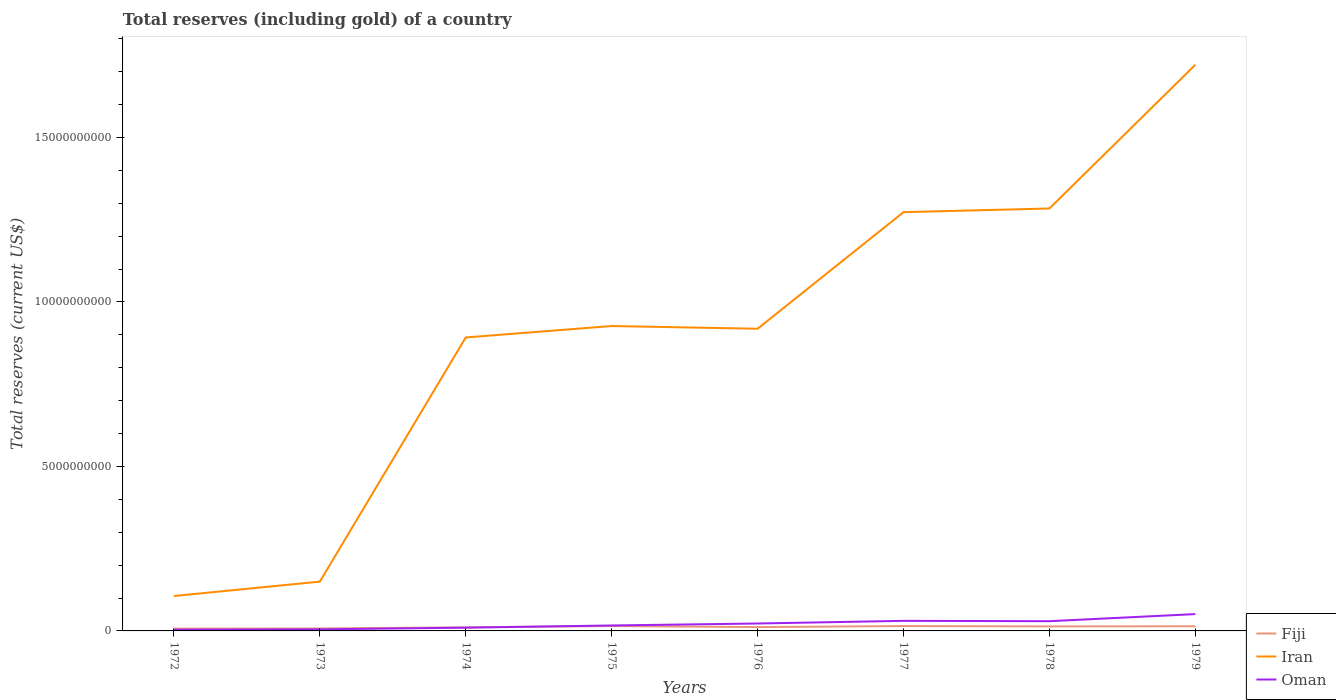How many different coloured lines are there?
Ensure brevity in your answer.  3. Is the number of lines equal to the number of legend labels?
Provide a short and direct response. Yes. Across all years, what is the maximum total reserves (including gold) in Oman?
Provide a succinct answer. 3.73e+07. What is the total total reserves (including gold) in Iran in the graph?
Offer a very short reply. -1.61e+1. What is the difference between the highest and the second highest total reserves (including gold) in Fiji?
Provide a short and direct response. 7.92e+07. Is the total reserves (including gold) in Fiji strictly greater than the total reserves (including gold) in Oman over the years?
Your response must be concise. No. What is the difference between two consecutive major ticks on the Y-axis?
Ensure brevity in your answer.  5.00e+09. Are the values on the major ticks of Y-axis written in scientific E-notation?
Offer a terse response. No. Does the graph contain grids?
Provide a short and direct response. No. How many legend labels are there?
Provide a succinct answer. 3. What is the title of the graph?
Provide a short and direct response. Total reserves (including gold) of a country. What is the label or title of the Y-axis?
Provide a succinct answer. Total reserves (current US$). What is the Total reserves (current US$) of Fiji in 1972?
Make the answer very short. 6.94e+07. What is the Total reserves (current US$) of Iran in 1972?
Give a very brief answer. 1.06e+09. What is the Total reserves (current US$) of Oman in 1972?
Give a very brief answer. 3.73e+07. What is the Total reserves (current US$) of Fiji in 1973?
Your response must be concise. 7.39e+07. What is the Total reserves (current US$) of Iran in 1973?
Ensure brevity in your answer.  1.50e+09. What is the Total reserves (current US$) in Oman in 1973?
Offer a very short reply. 4.86e+07. What is the Total reserves (current US$) in Fiji in 1974?
Keep it short and to the point. 1.09e+08. What is the Total reserves (current US$) in Iran in 1974?
Keep it short and to the point. 8.92e+09. What is the Total reserves (current US$) of Oman in 1974?
Provide a short and direct response. 9.85e+07. What is the Total reserves (current US$) of Fiji in 1975?
Make the answer very short. 1.49e+08. What is the Total reserves (current US$) of Iran in 1975?
Give a very brief answer. 9.27e+09. What is the Total reserves (current US$) in Oman in 1975?
Give a very brief answer. 1.66e+08. What is the Total reserves (current US$) of Fiji in 1976?
Provide a succinct answer. 1.16e+08. What is the Total reserves (current US$) in Iran in 1976?
Keep it short and to the point. 9.18e+09. What is the Total reserves (current US$) of Oman in 1976?
Provide a short and direct response. 2.26e+08. What is the Total reserves (current US$) of Fiji in 1977?
Your answer should be compact. 1.48e+08. What is the Total reserves (current US$) of Iran in 1977?
Ensure brevity in your answer.  1.27e+1. What is the Total reserves (current US$) in Oman in 1977?
Ensure brevity in your answer.  3.06e+08. What is the Total reserves (current US$) of Fiji in 1978?
Give a very brief answer. 1.37e+08. What is the Total reserves (current US$) in Iran in 1978?
Provide a short and direct response. 1.28e+1. What is the Total reserves (current US$) of Oman in 1978?
Give a very brief answer. 2.96e+08. What is the Total reserves (current US$) of Fiji in 1979?
Your response must be concise. 1.42e+08. What is the Total reserves (current US$) of Iran in 1979?
Your answer should be very brief. 1.72e+1. What is the Total reserves (current US$) in Oman in 1979?
Keep it short and to the point. 5.11e+08. Across all years, what is the maximum Total reserves (current US$) of Fiji?
Provide a short and direct response. 1.49e+08. Across all years, what is the maximum Total reserves (current US$) of Iran?
Make the answer very short. 1.72e+1. Across all years, what is the maximum Total reserves (current US$) of Oman?
Ensure brevity in your answer.  5.11e+08. Across all years, what is the minimum Total reserves (current US$) in Fiji?
Keep it short and to the point. 6.94e+07. Across all years, what is the minimum Total reserves (current US$) of Iran?
Provide a short and direct response. 1.06e+09. Across all years, what is the minimum Total reserves (current US$) in Oman?
Provide a short and direct response. 3.73e+07. What is the total Total reserves (current US$) of Fiji in the graph?
Your answer should be compact. 9.44e+08. What is the total Total reserves (current US$) of Iran in the graph?
Offer a very short reply. 7.27e+1. What is the total Total reserves (current US$) in Oman in the graph?
Offer a very short reply. 1.69e+09. What is the difference between the Total reserves (current US$) of Fiji in 1972 and that in 1973?
Give a very brief answer. -4.53e+06. What is the difference between the Total reserves (current US$) in Iran in 1972 and that in 1973?
Provide a succinct answer. -4.37e+08. What is the difference between the Total reserves (current US$) in Oman in 1972 and that in 1973?
Provide a succinct answer. -1.13e+07. What is the difference between the Total reserves (current US$) in Fiji in 1972 and that in 1974?
Offer a very short reply. -3.97e+07. What is the difference between the Total reserves (current US$) in Iran in 1972 and that in 1974?
Provide a short and direct response. -7.86e+09. What is the difference between the Total reserves (current US$) of Oman in 1972 and that in 1974?
Keep it short and to the point. -6.12e+07. What is the difference between the Total reserves (current US$) of Fiji in 1972 and that in 1975?
Your response must be concise. -7.92e+07. What is the difference between the Total reserves (current US$) in Iran in 1972 and that in 1975?
Provide a short and direct response. -8.21e+09. What is the difference between the Total reserves (current US$) of Oman in 1972 and that in 1975?
Your answer should be very brief. -1.28e+08. What is the difference between the Total reserves (current US$) in Fiji in 1972 and that in 1976?
Make the answer very short. -4.69e+07. What is the difference between the Total reserves (current US$) of Iran in 1972 and that in 1976?
Provide a short and direct response. -8.12e+09. What is the difference between the Total reserves (current US$) of Oman in 1972 and that in 1976?
Provide a succinct answer. -1.88e+08. What is the difference between the Total reserves (current US$) in Fiji in 1972 and that in 1977?
Your response must be concise. -7.86e+07. What is the difference between the Total reserves (current US$) in Iran in 1972 and that in 1977?
Your response must be concise. -1.17e+1. What is the difference between the Total reserves (current US$) in Oman in 1972 and that in 1977?
Your response must be concise. -2.69e+08. What is the difference between the Total reserves (current US$) of Fiji in 1972 and that in 1978?
Provide a short and direct response. -6.72e+07. What is the difference between the Total reserves (current US$) in Iran in 1972 and that in 1978?
Offer a terse response. -1.18e+1. What is the difference between the Total reserves (current US$) of Oman in 1972 and that in 1978?
Provide a short and direct response. -2.59e+08. What is the difference between the Total reserves (current US$) in Fiji in 1972 and that in 1979?
Your response must be concise. -7.28e+07. What is the difference between the Total reserves (current US$) of Iran in 1972 and that in 1979?
Give a very brief answer. -1.61e+1. What is the difference between the Total reserves (current US$) in Oman in 1972 and that in 1979?
Offer a terse response. -4.74e+08. What is the difference between the Total reserves (current US$) in Fiji in 1973 and that in 1974?
Offer a terse response. -3.52e+07. What is the difference between the Total reserves (current US$) in Iran in 1973 and that in 1974?
Offer a very short reply. -7.42e+09. What is the difference between the Total reserves (current US$) in Oman in 1973 and that in 1974?
Offer a terse response. -4.99e+07. What is the difference between the Total reserves (current US$) in Fiji in 1973 and that in 1975?
Offer a very short reply. -7.46e+07. What is the difference between the Total reserves (current US$) in Iran in 1973 and that in 1975?
Offer a terse response. -7.77e+09. What is the difference between the Total reserves (current US$) in Oman in 1973 and that in 1975?
Make the answer very short. -1.17e+08. What is the difference between the Total reserves (current US$) in Fiji in 1973 and that in 1976?
Ensure brevity in your answer.  -4.24e+07. What is the difference between the Total reserves (current US$) in Iran in 1973 and that in 1976?
Provide a succinct answer. -7.69e+09. What is the difference between the Total reserves (current US$) in Oman in 1973 and that in 1976?
Offer a very short reply. -1.77e+08. What is the difference between the Total reserves (current US$) of Fiji in 1973 and that in 1977?
Give a very brief answer. -7.41e+07. What is the difference between the Total reserves (current US$) in Iran in 1973 and that in 1977?
Your answer should be compact. -1.12e+1. What is the difference between the Total reserves (current US$) in Oman in 1973 and that in 1977?
Offer a very short reply. -2.58e+08. What is the difference between the Total reserves (current US$) in Fiji in 1973 and that in 1978?
Your response must be concise. -6.26e+07. What is the difference between the Total reserves (current US$) in Iran in 1973 and that in 1978?
Offer a terse response. -1.13e+1. What is the difference between the Total reserves (current US$) in Oman in 1973 and that in 1978?
Your response must be concise. -2.47e+08. What is the difference between the Total reserves (current US$) in Fiji in 1973 and that in 1979?
Your answer should be very brief. -6.82e+07. What is the difference between the Total reserves (current US$) in Iran in 1973 and that in 1979?
Your answer should be very brief. -1.57e+1. What is the difference between the Total reserves (current US$) of Oman in 1973 and that in 1979?
Your answer should be very brief. -4.63e+08. What is the difference between the Total reserves (current US$) of Fiji in 1974 and that in 1975?
Give a very brief answer. -3.94e+07. What is the difference between the Total reserves (current US$) of Iran in 1974 and that in 1975?
Your answer should be very brief. -3.48e+08. What is the difference between the Total reserves (current US$) in Oman in 1974 and that in 1975?
Make the answer very short. -6.70e+07. What is the difference between the Total reserves (current US$) of Fiji in 1974 and that in 1976?
Your answer should be very brief. -7.17e+06. What is the difference between the Total reserves (current US$) in Iran in 1974 and that in 1976?
Your answer should be very brief. -2.65e+08. What is the difference between the Total reserves (current US$) of Oman in 1974 and that in 1976?
Your response must be concise. -1.27e+08. What is the difference between the Total reserves (current US$) in Fiji in 1974 and that in 1977?
Keep it short and to the point. -3.89e+07. What is the difference between the Total reserves (current US$) in Iran in 1974 and that in 1977?
Give a very brief answer. -3.81e+09. What is the difference between the Total reserves (current US$) of Oman in 1974 and that in 1977?
Give a very brief answer. -2.08e+08. What is the difference between the Total reserves (current US$) in Fiji in 1974 and that in 1978?
Your response must be concise. -2.74e+07. What is the difference between the Total reserves (current US$) of Iran in 1974 and that in 1978?
Your answer should be compact. -3.92e+09. What is the difference between the Total reserves (current US$) of Oman in 1974 and that in 1978?
Your answer should be very brief. -1.97e+08. What is the difference between the Total reserves (current US$) in Fiji in 1974 and that in 1979?
Provide a short and direct response. -3.30e+07. What is the difference between the Total reserves (current US$) of Iran in 1974 and that in 1979?
Offer a very short reply. -8.29e+09. What is the difference between the Total reserves (current US$) in Oman in 1974 and that in 1979?
Provide a succinct answer. -4.13e+08. What is the difference between the Total reserves (current US$) in Fiji in 1975 and that in 1976?
Offer a very short reply. 3.23e+07. What is the difference between the Total reserves (current US$) in Iran in 1975 and that in 1976?
Make the answer very short. 8.29e+07. What is the difference between the Total reserves (current US$) in Oman in 1975 and that in 1976?
Provide a short and direct response. -6.03e+07. What is the difference between the Total reserves (current US$) in Fiji in 1975 and that in 1977?
Your answer should be very brief. 5.37e+05. What is the difference between the Total reserves (current US$) in Iran in 1975 and that in 1977?
Ensure brevity in your answer.  -3.46e+09. What is the difference between the Total reserves (current US$) of Oman in 1975 and that in 1977?
Give a very brief answer. -1.41e+08. What is the difference between the Total reserves (current US$) in Fiji in 1975 and that in 1978?
Provide a succinct answer. 1.20e+07. What is the difference between the Total reserves (current US$) of Iran in 1975 and that in 1978?
Offer a terse response. -3.57e+09. What is the difference between the Total reserves (current US$) in Oman in 1975 and that in 1978?
Keep it short and to the point. -1.30e+08. What is the difference between the Total reserves (current US$) in Fiji in 1975 and that in 1979?
Make the answer very short. 6.42e+06. What is the difference between the Total reserves (current US$) in Iran in 1975 and that in 1979?
Keep it short and to the point. -7.94e+09. What is the difference between the Total reserves (current US$) in Oman in 1975 and that in 1979?
Offer a terse response. -3.46e+08. What is the difference between the Total reserves (current US$) of Fiji in 1976 and that in 1977?
Ensure brevity in your answer.  -3.17e+07. What is the difference between the Total reserves (current US$) of Iran in 1976 and that in 1977?
Your response must be concise. -3.54e+09. What is the difference between the Total reserves (current US$) in Oman in 1976 and that in 1977?
Ensure brevity in your answer.  -8.05e+07. What is the difference between the Total reserves (current US$) of Fiji in 1976 and that in 1978?
Give a very brief answer. -2.03e+07. What is the difference between the Total reserves (current US$) of Iran in 1976 and that in 1978?
Make the answer very short. -3.66e+09. What is the difference between the Total reserves (current US$) in Oman in 1976 and that in 1978?
Give a very brief answer. -7.02e+07. What is the difference between the Total reserves (current US$) in Fiji in 1976 and that in 1979?
Make the answer very short. -2.58e+07. What is the difference between the Total reserves (current US$) in Iran in 1976 and that in 1979?
Ensure brevity in your answer.  -8.02e+09. What is the difference between the Total reserves (current US$) of Oman in 1976 and that in 1979?
Your answer should be very brief. -2.86e+08. What is the difference between the Total reserves (current US$) of Fiji in 1977 and that in 1978?
Provide a succinct answer. 1.15e+07. What is the difference between the Total reserves (current US$) of Iran in 1977 and that in 1978?
Your response must be concise. -1.11e+08. What is the difference between the Total reserves (current US$) of Oman in 1977 and that in 1978?
Your answer should be compact. 1.03e+07. What is the difference between the Total reserves (current US$) of Fiji in 1977 and that in 1979?
Provide a short and direct response. 5.89e+06. What is the difference between the Total reserves (current US$) of Iran in 1977 and that in 1979?
Your answer should be very brief. -4.48e+09. What is the difference between the Total reserves (current US$) of Oman in 1977 and that in 1979?
Offer a very short reply. -2.05e+08. What is the difference between the Total reserves (current US$) in Fiji in 1978 and that in 1979?
Your answer should be very brief. -5.57e+06. What is the difference between the Total reserves (current US$) of Iran in 1978 and that in 1979?
Offer a very short reply. -4.37e+09. What is the difference between the Total reserves (current US$) in Oman in 1978 and that in 1979?
Keep it short and to the point. -2.15e+08. What is the difference between the Total reserves (current US$) of Fiji in 1972 and the Total reserves (current US$) of Iran in 1973?
Your answer should be compact. -1.43e+09. What is the difference between the Total reserves (current US$) of Fiji in 1972 and the Total reserves (current US$) of Oman in 1973?
Make the answer very short. 2.08e+07. What is the difference between the Total reserves (current US$) in Iran in 1972 and the Total reserves (current US$) in Oman in 1973?
Keep it short and to the point. 1.01e+09. What is the difference between the Total reserves (current US$) of Fiji in 1972 and the Total reserves (current US$) of Iran in 1974?
Your answer should be very brief. -8.85e+09. What is the difference between the Total reserves (current US$) of Fiji in 1972 and the Total reserves (current US$) of Oman in 1974?
Offer a very short reply. -2.91e+07. What is the difference between the Total reserves (current US$) in Iran in 1972 and the Total reserves (current US$) in Oman in 1974?
Ensure brevity in your answer.  9.63e+08. What is the difference between the Total reserves (current US$) of Fiji in 1972 and the Total reserves (current US$) of Iran in 1975?
Your response must be concise. -9.20e+09. What is the difference between the Total reserves (current US$) in Fiji in 1972 and the Total reserves (current US$) in Oman in 1975?
Keep it short and to the point. -9.61e+07. What is the difference between the Total reserves (current US$) in Iran in 1972 and the Total reserves (current US$) in Oman in 1975?
Ensure brevity in your answer.  8.96e+08. What is the difference between the Total reserves (current US$) in Fiji in 1972 and the Total reserves (current US$) in Iran in 1976?
Your answer should be compact. -9.12e+09. What is the difference between the Total reserves (current US$) in Fiji in 1972 and the Total reserves (current US$) in Oman in 1976?
Provide a short and direct response. -1.56e+08. What is the difference between the Total reserves (current US$) in Iran in 1972 and the Total reserves (current US$) in Oman in 1976?
Offer a terse response. 8.35e+08. What is the difference between the Total reserves (current US$) in Fiji in 1972 and the Total reserves (current US$) in Iran in 1977?
Your response must be concise. -1.27e+1. What is the difference between the Total reserves (current US$) in Fiji in 1972 and the Total reserves (current US$) in Oman in 1977?
Keep it short and to the point. -2.37e+08. What is the difference between the Total reserves (current US$) in Iran in 1972 and the Total reserves (current US$) in Oman in 1977?
Your answer should be very brief. 7.55e+08. What is the difference between the Total reserves (current US$) in Fiji in 1972 and the Total reserves (current US$) in Iran in 1978?
Give a very brief answer. -1.28e+1. What is the difference between the Total reserves (current US$) in Fiji in 1972 and the Total reserves (current US$) in Oman in 1978?
Give a very brief answer. -2.27e+08. What is the difference between the Total reserves (current US$) in Iran in 1972 and the Total reserves (current US$) in Oman in 1978?
Make the answer very short. 7.65e+08. What is the difference between the Total reserves (current US$) of Fiji in 1972 and the Total reserves (current US$) of Iran in 1979?
Provide a succinct answer. -1.71e+1. What is the difference between the Total reserves (current US$) of Fiji in 1972 and the Total reserves (current US$) of Oman in 1979?
Give a very brief answer. -4.42e+08. What is the difference between the Total reserves (current US$) of Iran in 1972 and the Total reserves (current US$) of Oman in 1979?
Provide a short and direct response. 5.50e+08. What is the difference between the Total reserves (current US$) of Fiji in 1973 and the Total reserves (current US$) of Iran in 1974?
Your answer should be compact. -8.85e+09. What is the difference between the Total reserves (current US$) in Fiji in 1973 and the Total reserves (current US$) in Oman in 1974?
Your answer should be compact. -2.46e+07. What is the difference between the Total reserves (current US$) of Iran in 1973 and the Total reserves (current US$) of Oman in 1974?
Your answer should be compact. 1.40e+09. What is the difference between the Total reserves (current US$) of Fiji in 1973 and the Total reserves (current US$) of Iran in 1975?
Offer a terse response. -9.19e+09. What is the difference between the Total reserves (current US$) of Fiji in 1973 and the Total reserves (current US$) of Oman in 1975?
Give a very brief answer. -9.16e+07. What is the difference between the Total reserves (current US$) of Iran in 1973 and the Total reserves (current US$) of Oman in 1975?
Your response must be concise. 1.33e+09. What is the difference between the Total reserves (current US$) in Fiji in 1973 and the Total reserves (current US$) in Iran in 1976?
Your answer should be compact. -9.11e+09. What is the difference between the Total reserves (current US$) of Fiji in 1973 and the Total reserves (current US$) of Oman in 1976?
Your answer should be compact. -1.52e+08. What is the difference between the Total reserves (current US$) in Iran in 1973 and the Total reserves (current US$) in Oman in 1976?
Offer a very short reply. 1.27e+09. What is the difference between the Total reserves (current US$) of Fiji in 1973 and the Total reserves (current US$) of Iran in 1977?
Offer a very short reply. -1.27e+1. What is the difference between the Total reserves (current US$) in Fiji in 1973 and the Total reserves (current US$) in Oman in 1977?
Offer a very short reply. -2.32e+08. What is the difference between the Total reserves (current US$) in Iran in 1973 and the Total reserves (current US$) in Oman in 1977?
Your answer should be compact. 1.19e+09. What is the difference between the Total reserves (current US$) in Fiji in 1973 and the Total reserves (current US$) in Iran in 1978?
Your answer should be very brief. -1.28e+1. What is the difference between the Total reserves (current US$) in Fiji in 1973 and the Total reserves (current US$) in Oman in 1978?
Your answer should be compact. -2.22e+08. What is the difference between the Total reserves (current US$) of Iran in 1973 and the Total reserves (current US$) of Oman in 1978?
Keep it short and to the point. 1.20e+09. What is the difference between the Total reserves (current US$) in Fiji in 1973 and the Total reserves (current US$) in Iran in 1979?
Provide a short and direct response. -1.71e+1. What is the difference between the Total reserves (current US$) of Fiji in 1973 and the Total reserves (current US$) of Oman in 1979?
Offer a terse response. -4.37e+08. What is the difference between the Total reserves (current US$) of Iran in 1973 and the Total reserves (current US$) of Oman in 1979?
Keep it short and to the point. 9.87e+08. What is the difference between the Total reserves (current US$) of Fiji in 1974 and the Total reserves (current US$) of Iran in 1975?
Give a very brief answer. -9.16e+09. What is the difference between the Total reserves (current US$) of Fiji in 1974 and the Total reserves (current US$) of Oman in 1975?
Give a very brief answer. -5.64e+07. What is the difference between the Total reserves (current US$) in Iran in 1974 and the Total reserves (current US$) in Oman in 1975?
Your answer should be compact. 8.75e+09. What is the difference between the Total reserves (current US$) of Fiji in 1974 and the Total reserves (current US$) of Iran in 1976?
Make the answer very short. -9.08e+09. What is the difference between the Total reserves (current US$) of Fiji in 1974 and the Total reserves (current US$) of Oman in 1976?
Your answer should be compact. -1.17e+08. What is the difference between the Total reserves (current US$) of Iran in 1974 and the Total reserves (current US$) of Oman in 1976?
Provide a short and direct response. 8.69e+09. What is the difference between the Total reserves (current US$) in Fiji in 1974 and the Total reserves (current US$) in Iran in 1977?
Your answer should be very brief. -1.26e+1. What is the difference between the Total reserves (current US$) in Fiji in 1974 and the Total reserves (current US$) in Oman in 1977?
Provide a succinct answer. -1.97e+08. What is the difference between the Total reserves (current US$) of Iran in 1974 and the Total reserves (current US$) of Oman in 1977?
Provide a succinct answer. 8.61e+09. What is the difference between the Total reserves (current US$) of Fiji in 1974 and the Total reserves (current US$) of Iran in 1978?
Make the answer very short. -1.27e+1. What is the difference between the Total reserves (current US$) in Fiji in 1974 and the Total reserves (current US$) in Oman in 1978?
Your response must be concise. -1.87e+08. What is the difference between the Total reserves (current US$) in Iran in 1974 and the Total reserves (current US$) in Oman in 1978?
Give a very brief answer. 8.62e+09. What is the difference between the Total reserves (current US$) of Fiji in 1974 and the Total reserves (current US$) of Iran in 1979?
Ensure brevity in your answer.  -1.71e+1. What is the difference between the Total reserves (current US$) in Fiji in 1974 and the Total reserves (current US$) in Oman in 1979?
Give a very brief answer. -4.02e+08. What is the difference between the Total reserves (current US$) in Iran in 1974 and the Total reserves (current US$) in Oman in 1979?
Offer a terse response. 8.41e+09. What is the difference between the Total reserves (current US$) in Fiji in 1975 and the Total reserves (current US$) in Iran in 1976?
Ensure brevity in your answer.  -9.04e+09. What is the difference between the Total reserves (current US$) in Fiji in 1975 and the Total reserves (current US$) in Oman in 1976?
Your answer should be compact. -7.72e+07. What is the difference between the Total reserves (current US$) in Iran in 1975 and the Total reserves (current US$) in Oman in 1976?
Offer a terse response. 9.04e+09. What is the difference between the Total reserves (current US$) of Fiji in 1975 and the Total reserves (current US$) of Iran in 1977?
Your answer should be very brief. -1.26e+1. What is the difference between the Total reserves (current US$) in Fiji in 1975 and the Total reserves (current US$) in Oman in 1977?
Your answer should be very brief. -1.58e+08. What is the difference between the Total reserves (current US$) in Iran in 1975 and the Total reserves (current US$) in Oman in 1977?
Your answer should be very brief. 8.96e+09. What is the difference between the Total reserves (current US$) in Fiji in 1975 and the Total reserves (current US$) in Iran in 1978?
Ensure brevity in your answer.  -1.27e+1. What is the difference between the Total reserves (current US$) in Fiji in 1975 and the Total reserves (current US$) in Oman in 1978?
Offer a terse response. -1.47e+08. What is the difference between the Total reserves (current US$) of Iran in 1975 and the Total reserves (current US$) of Oman in 1978?
Make the answer very short. 8.97e+09. What is the difference between the Total reserves (current US$) in Fiji in 1975 and the Total reserves (current US$) in Iran in 1979?
Provide a succinct answer. -1.71e+1. What is the difference between the Total reserves (current US$) of Fiji in 1975 and the Total reserves (current US$) of Oman in 1979?
Offer a terse response. -3.63e+08. What is the difference between the Total reserves (current US$) of Iran in 1975 and the Total reserves (current US$) of Oman in 1979?
Your response must be concise. 8.76e+09. What is the difference between the Total reserves (current US$) in Fiji in 1976 and the Total reserves (current US$) in Iran in 1977?
Make the answer very short. -1.26e+1. What is the difference between the Total reserves (current US$) of Fiji in 1976 and the Total reserves (current US$) of Oman in 1977?
Provide a succinct answer. -1.90e+08. What is the difference between the Total reserves (current US$) of Iran in 1976 and the Total reserves (current US$) of Oman in 1977?
Provide a succinct answer. 8.88e+09. What is the difference between the Total reserves (current US$) in Fiji in 1976 and the Total reserves (current US$) in Iran in 1978?
Your answer should be compact. -1.27e+1. What is the difference between the Total reserves (current US$) of Fiji in 1976 and the Total reserves (current US$) of Oman in 1978?
Make the answer very short. -1.80e+08. What is the difference between the Total reserves (current US$) in Iran in 1976 and the Total reserves (current US$) in Oman in 1978?
Give a very brief answer. 8.89e+09. What is the difference between the Total reserves (current US$) in Fiji in 1976 and the Total reserves (current US$) in Iran in 1979?
Your response must be concise. -1.71e+1. What is the difference between the Total reserves (current US$) of Fiji in 1976 and the Total reserves (current US$) of Oman in 1979?
Make the answer very short. -3.95e+08. What is the difference between the Total reserves (current US$) in Iran in 1976 and the Total reserves (current US$) in Oman in 1979?
Offer a terse response. 8.67e+09. What is the difference between the Total reserves (current US$) of Fiji in 1977 and the Total reserves (current US$) of Iran in 1978?
Offer a very short reply. -1.27e+1. What is the difference between the Total reserves (current US$) of Fiji in 1977 and the Total reserves (current US$) of Oman in 1978?
Make the answer very short. -1.48e+08. What is the difference between the Total reserves (current US$) in Iran in 1977 and the Total reserves (current US$) in Oman in 1978?
Make the answer very short. 1.24e+1. What is the difference between the Total reserves (current US$) in Fiji in 1977 and the Total reserves (current US$) in Iran in 1979?
Your response must be concise. -1.71e+1. What is the difference between the Total reserves (current US$) of Fiji in 1977 and the Total reserves (current US$) of Oman in 1979?
Keep it short and to the point. -3.63e+08. What is the difference between the Total reserves (current US$) in Iran in 1977 and the Total reserves (current US$) in Oman in 1979?
Provide a short and direct response. 1.22e+1. What is the difference between the Total reserves (current US$) of Fiji in 1978 and the Total reserves (current US$) of Iran in 1979?
Provide a short and direct response. -1.71e+1. What is the difference between the Total reserves (current US$) of Fiji in 1978 and the Total reserves (current US$) of Oman in 1979?
Your answer should be very brief. -3.75e+08. What is the difference between the Total reserves (current US$) in Iran in 1978 and the Total reserves (current US$) in Oman in 1979?
Ensure brevity in your answer.  1.23e+1. What is the average Total reserves (current US$) of Fiji per year?
Your answer should be very brief. 1.18e+08. What is the average Total reserves (current US$) of Iran per year?
Your answer should be very brief. 9.09e+09. What is the average Total reserves (current US$) in Oman per year?
Provide a short and direct response. 2.11e+08. In the year 1972, what is the difference between the Total reserves (current US$) in Fiji and Total reserves (current US$) in Iran?
Provide a succinct answer. -9.92e+08. In the year 1972, what is the difference between the Total reserves (current US$) of Fiji and Total reserves (current US$) of Oman?
Ensure brevity in your answer.  3.21e+07. In the year 1972, what is the difference between the Total reserves (current US$) of Iran and Total reserves (current US$) of Oman?
Ensure brevity in your answer.  1.02e+09. In the year 1973, what is the difference between the Total reserves (current US$) in Fiji and Total reserves (current US$) in Iran?
Your answer should be compact. -1.42e+09. In the year 1973, what is the difference between the Total reserves (current US$) of Fiji and Total reserves (current US$) of Oman?
Your answer should be compact. 2.53e+07. In the year 1973, what is the difference between the Total reserves (current US$) of Iran and Total reserves (current US$) of Oman?
Make the answer very short. 1.45e+09. In the year 1974, what is the difference between the Total reserves (current US$) of Fiji and Total reserves (current US$) of Iran?
Keep it short and to the point. -8.81e+09. In the year 1974, what is the difference between the Total reserves (current US$) of Fiji and Total reserves (current US$) of Oman?
Make the answer very short. 1.06e+07. In the year 1974, what is the difference between the Total reserves (current US$) of Iran and Total reserves (current US$) of Oman?
Offer a terse response. 8.82e+09. In the year 1975, what is the difference between the Total reserves (current US$) in Fiji and Total reserves (current US$) in Iran?
Provide a succinct answer. -9.12e+09. In the year 1975, what is the difference between the Total reserves (current US$) in Fiji and Total reserves (current US$) in Oman?
Keep it short and to the point. -1.70e+07. In the year 1975, what is the difference between the Total reserves (current US$) in Iran and Total reserves (current US$) in Oman?
Keep it short and to the point. 9.10e+09. In the year 1976, what is the difference between the Total reserves (current US$) of Fiji and Total reserves (current US$) of Iran?
Make the answer very short. -9.07e+09. In the year 1976, what is the difference between the Total reserves (current US$) in Fiji and Total reserves (current US$) in Oman?
Make the answer very short. -1.09e+08. In the year 1976, what is the difference between the Total reserves (current US$) in Iran and Total reserves (current US$) in Oman?
Keep it short and to the point. 8.96e+09. In the year 1977, what is the difference between the Total reserves (current US$) of Fiji and Total reserves (current US$) of Iran?
Ensure brevity in your answer.  -1.26e+1. In the year 1977, what is the difference between the Total reserves (current US$) in Fiji and Total reserves (current US$) in Oman?
Provide a succinct answer. -1.58e+08. In the year 1977, what is the difference between the Total reserves (current US$) of Iran and Total reserves (current US$) of Oman?
Provide a short and direct response. 1.24e+1. In the year 1978, what is the difference between the Total reserves (current US$) in Fiji and Total reserves (current US$) in Iran?
Ensure brevity in your answer.  -1.27e+1. In the year 1978, what is the difference between the Total reserves (current US$) of Fiji and Total reserves (current US$) of Oman?
Your answer should be compact. -1.59e+08. In the year 1978, what is the difference between the Total reserves (current US$) of Iran and Total reserves (current US$) of Oman?
Offer a terse response. 1.25e+1. In the year 1979, what is the difference between the Total reserves (current US$) of Fiji and Total reserves (current US$) of Iran?
Offer a terse response. -1.71e+1. In the year 1979, what is the difference between the Total reserves (current US$) of Fiji and Total reserves (current US$) of Oman?
Ensure brevity in your answer.  -3.69e+08. In the year 1979, what is the difference between the Total reserves (current US$) of Iran and Total reserves (current US$) of Oman?
Your answer should be very brief. 1.67e+1. What is the ratio of the Total reserves (current US$) of Fiji in 1972 to that in 1973?
Make the answer very short. 0.94. What is the ratio of the Total reserves (current US$) of Iran in 1972 to that in 1973?
Provide a short and direct response. 0.71. What is the ratio of the Total reserves (current US$) in Oman in 1972 to that in 1973?
Your answer should be compact. 0.77. What is the ratio of the Total reserves (current US$) of Fiji in 1972 to that in 1974?
Provide a succinct answer. 0.64. What is the ratio of the Total reserves (current US$) in Iran in 1972 to that in 1974?
Provide a succinct answer. 0.12. What is the ratio of the Total reserves (current US$) of Oman in 1972 to that in 1974?
Keep it short and to the point. 0.38. What is the ratio of the Total reserves (current US$) of Fiji in 1972 to that in 1975?
Provide a short and direct response. 0.47. What is the ratio of the Total reserves (current US$) in Iran in 1972 to that in 1975?
Your answer should be compact. 0.11. What is the ratio of the Total reserves (current US$) of Oman in 1972 to that in 1975?
Your response must be concise. 0.23. What is the ratio of the Total reserves (current US$) in Fiji in 1972 to that in 1976?
Give a very brief answer. 0.6. What is the ratio of the Total reserves (current US$) in Iran in 1972 to that in 1976?
Your answer should be compact. 0.12. What is the ratio of the Total reserves (current US$) of Oman in 1972 to that in 1976?
Your answer should be compact. 0.17. What is the ratio of the Total reserves (current US$) in Fiji in 1972 to that in 1977?
Give a very brief answer. 0.47. What is the ratio of the Total reserves (current US$) of Iran in 1972 to that in 1977?
Provide a succinct answer. 0.08. What is the ratio of the Total reserves (current US$) in Oman in 1972 to that in 1977?
Give a very brief answer. 0.12. What is the ratio of the Total reserves (current US$) of Fiji in 1972 to that in 1978?
Provide a succinct answer. 0.51. What is the ratio of the Total reserves (current US$) in Iran in 1972 to that in 1978?
Your answer should be compact. 0.08. What is the ratio of the Total reserves (current US$) of Oman in 1972 to that in 1978?
Give a very brief answer. 0.13. What is the ratio of the Total reserves (current US$) in Fiji in 1972 to that in 1979?
Your answer should be compact. 0.49. What is the ratio of the Total reserves (current US$) in Iran in 1972 to that in 1979?
Make the answer very short. 0.06. What is the ratio of the Total reserves (current US$) of Oman in 1972 to that in 1979?
Give a very brief answer. 0.07. What is the ratio of the Total reserves (current US$) in Fiji in 1973 to that in 1974?
Your answer should be compact. 0.68. What is the ratio of the Total reserves (current US$) of Iran in 1973 to that in 1974?
Make the answer very short. 0.17. What is the ratio of the Total reserves (current US$) of Oman in 1973 to that in 1974?
Offer a very short reply. 0.49. What is the ratio of the Total reserves (current US$) of Fiji in 1973 to that in 1975?
Offer a terse response. 0.5. What is the ratio of the Total reserves (current US$) of Iran in 1973 to that in 1975?
Offer a terse response. 0.16. What is the ratio of the Total reserves (current US$) of Oman in 1973 to that in 1975?
Your answer should be compact. 0.29. What is the ratio of the Total reserves (current US$) of Fiji in 1973 to that in 1976?
Keep it short and to the point. 0.64. What is the ratio of the Total reserves (current US$) of Iran in 1973 to that in 1976?
Offer a terse response. 0.16. What is the ratio of the Total reserves (current US$) in Oman in 1973 to that in 1976?
Your response must be concise. 0.22. What is the ratio of the Total reserves (current US$) of Fiji in 1973 to that in 1977?
Provide a succinct answer. 0.5. What is the ratio of the Total reserves (current US$) of Iran in 1973 to that in 1977?
Your answer should be very brief. 0.12. What is the ratio of the Total reserves (current US$) of Oman in 1973 to that in 1977?
Your answer should be very brief. 0.16. What is the ratio of the Total reserves (current US$) of Fiji in 1973 to that in 1978?
Make the answer very short. 0.54. What is the ratio of the Total reserves (current US$) of Iran in 1973 to that in 1978?
Offer a very short reply. 0.12. What is the ratio of the Total reserves (current US$) in Oman in 1973 to that in 1978?
Provide a succinct answer. 0.16. What is the ratio of the Total reserves (current US$) in Fiji in 1973 to that in 1979?
Your response must be concise. 0.52. What is the ratio of the Total reserves (current US$) of Iran in 1973 to that in 1979?
Your answer should be compact. 0.09. What is the ratio of the Total reserves (current US$) of Oman in 1973 to that in 1979?
Your response must be concise. 0.1. What is the ratio of the Total reserves (current US$) of Fiji in 1974 to that in 1975?
Your answer should be compact. 0.73. What is the ratio of the Total reserves (current US$) of Iran in 1974 to that in 1975?
Keep it short and to the point. 0.96. What is the ratio of the Total reserves (current US$) of Oman in 1974 to that in 1975?
Your answer should be very brief. 0.6. What is the ratio of the Total reserves (current US$) of Fiji in 1974 to that in 1976?
Your answer should be very brief. 0.94. What is the ratio of the Total reserves (current US$) of Iran in 1974 to that in 1976?
Provide a short and direct response. 0.97. What is the ratio of the Total reserves (current US$) of Oman in 1974 to that in 1976?
Make the answer very short. 0.44. What is the ratio of the Total reserves (current US$) in Fiji in 1974 to that in 1977?
Your answer should be compact. 0.74. What is the ratio of the Total reserves (current US$) in Iran in 1974 to that in 1977?
Provide a succinct answer. 0.7. What is the ratio of the Total reserves (current US$) in Oman in 1974 to that in 1977?
Keep it short and to the point. 0.32. What is the ratio of the Total reserves (current US$) of Fiji in 1974 to that in 1978?
Your response must be concise. 0.8. What is the ratio of the Total reserves (current US$) in Iran in 1974 to that in 1978?
Provide a succinct answer. 0.69. What is the ratio of the Total reserves (current US$) in Oman in 1974 to that in 1978?
Ensure brevity in your answer.  0.33. What is the ratio of the Total reserves (current US$) of Fiji in 1974 to that in 1979?
Your answer should be compact. 0.77. What is the ratio of the Total reserves (current US$) in Iran in 1974 to that in 1979?
Provide a short and direct response. 0.52. What is the ratio of the Total reserves (current US$) in Oman in 1974 to that in 1979?
Offer a terse response. 0.19. What is the ratio of the Total reserves (current US$) of Fiji in 1975 to that in 1976?
Your answer should be compact. 1.28. What is the ratio of the Total reserves (current US$) in Iran in 1975 to that in 1976?
Give a very brief answer. 1.01. What is the ratio of the Total reserves (current US$) in Oman in 1975 to that in 1976?
Make the answer very short. 0.73. What is the ratio of the Total reserves (current US$) in Iran in 1975 to that in 1977?
Your answer should be compact. 0.73. What is the ratio of the Total reserves (current US$) of Oman in 1975 to that in 1977?
Give a very brief answer. 0.54. What is the ratio of the Total reserves (current US$) of Fiji in 1975 to that in 1978?
Give a very brief answer. 1.09. What is the ratio of the Total reserves (current US$) in Iran in 1975 to that in 1978?
Provide a succinct answer. 0.72. What is the ratio of the Total reserves (current US$) in Oman in 1975 to that in 1978?
Your response must be concise. 0.56. What is the ratio of the Total reserves (current US$) of Fiji in 1975 to that in 1979?
Offer a very short reply. 1.05. What is the ratio of the Total reserves (current US$) in Iran in 1975 to that in 1979?
Provide a short and direct response. 0.54. What is the ratio of the Total reserves (current US$) of Oman in 1975 to that in 1979?
Offer a very short reply. 0.32. What is the ratio of the Total reserves (current US$) in Fiji in 1976 to that in 1977?
Provide a succinct answer. 0.79. What is the ratio of the Total reserves (current US$) of Iran in 1976 to that in 1977?
Offer a terse response. 0.72. What is the ratio of the Total reserves (current US$) in Oman in 1976 to that in 1977?
Your response must be concise. 0.74. What is the ratio of the Total reserves (current US$) of Fiji in 1976 to that in 1978?
Your response must be concise. 0.85. What is the ratio of the Total reserves (current US$) of Iran in 1976 to that in 1978?
Provide a short and direct response. 0.72. What is the ratio of the Total reserves (current US$) in Oman in 1976 to that in 1978?
Give a very brief answer. 0.76. What is the ratio of the Total reserves (current US$) of Fiji in 1976 to that in 1979?
Give a very brief answer. 0.82. What is the ratio of the Total reserves (current US$) of Iran in 1976 to that in 1979?
Make the answer very short. 0.53. What is the ratio of the Total reserves (current US$) in Oman in 1976 to that in 1979?
Ensure brevity in your answer.  0.44. What is the ratio of the Total reserves (current US$) in Fiji in 1977 to that in 1978?
Provide a short and direct response. 1.08. What is the ratio of the Total reserves (current US$) of Iran in 1977 to that in 1978?
Keep it short and to the point. 0.99. What is the ratio of the Total reserves (current US$) in Oman in 1977 to that in 1978?
Ensure brevity in your answer.  1.03. What is the ratio of the Total reserves (current US$) of Fiji in 1977 to that in 1979?
Your response must be concise. 1.04. What is the ratio of the Total reserves (current US$) of Iran in 1977 to that in 1979?
Make the answer very short. 0.74. What is the ratio of the Total reserves (current US$) of Oman in 1977 to that in 1979?
Keep it short and to the point. 0.6. What is the ratio of the Total reserves (current US$) of Fiji in 1978 to that in 1979?
Offer a terse response. 0.96. What is the ratio of the Total reserves (current US$) in Iran in 1978 to that in 1979?
Offer a terse response. 0.75. What is the ratio of the Total reserves (current US$) of Oman in 1978 to that in 1979?
Your answer should be compact. 0.58. What is the difference between the highest and the second highest Total reserves (current US$) in Fiji?
Your answer should be very brief. 5.37e+05. What is the difference between the highest and the second highest Total reserves (current US$) in Iran?
Provide a succinct answer. 4.37e+09. What is the difference between the highest and the second highest Total reserves (current US$) of Oman?
Keep it short and to the point. 2.05e+08. What is the difference between the highest and the lowest Total reserves (current US$) in Fiji?
Make the answer very short. 7.92e+07. What is the difference between the highest and the lowest Total reserves (current US$) in Iran?
Give a very brief answer. 1.61e+1. What is the difference between the highest and the lowest Total reserves (current US$) in Oman?
Give a very brief answer. 4.74e+08. 